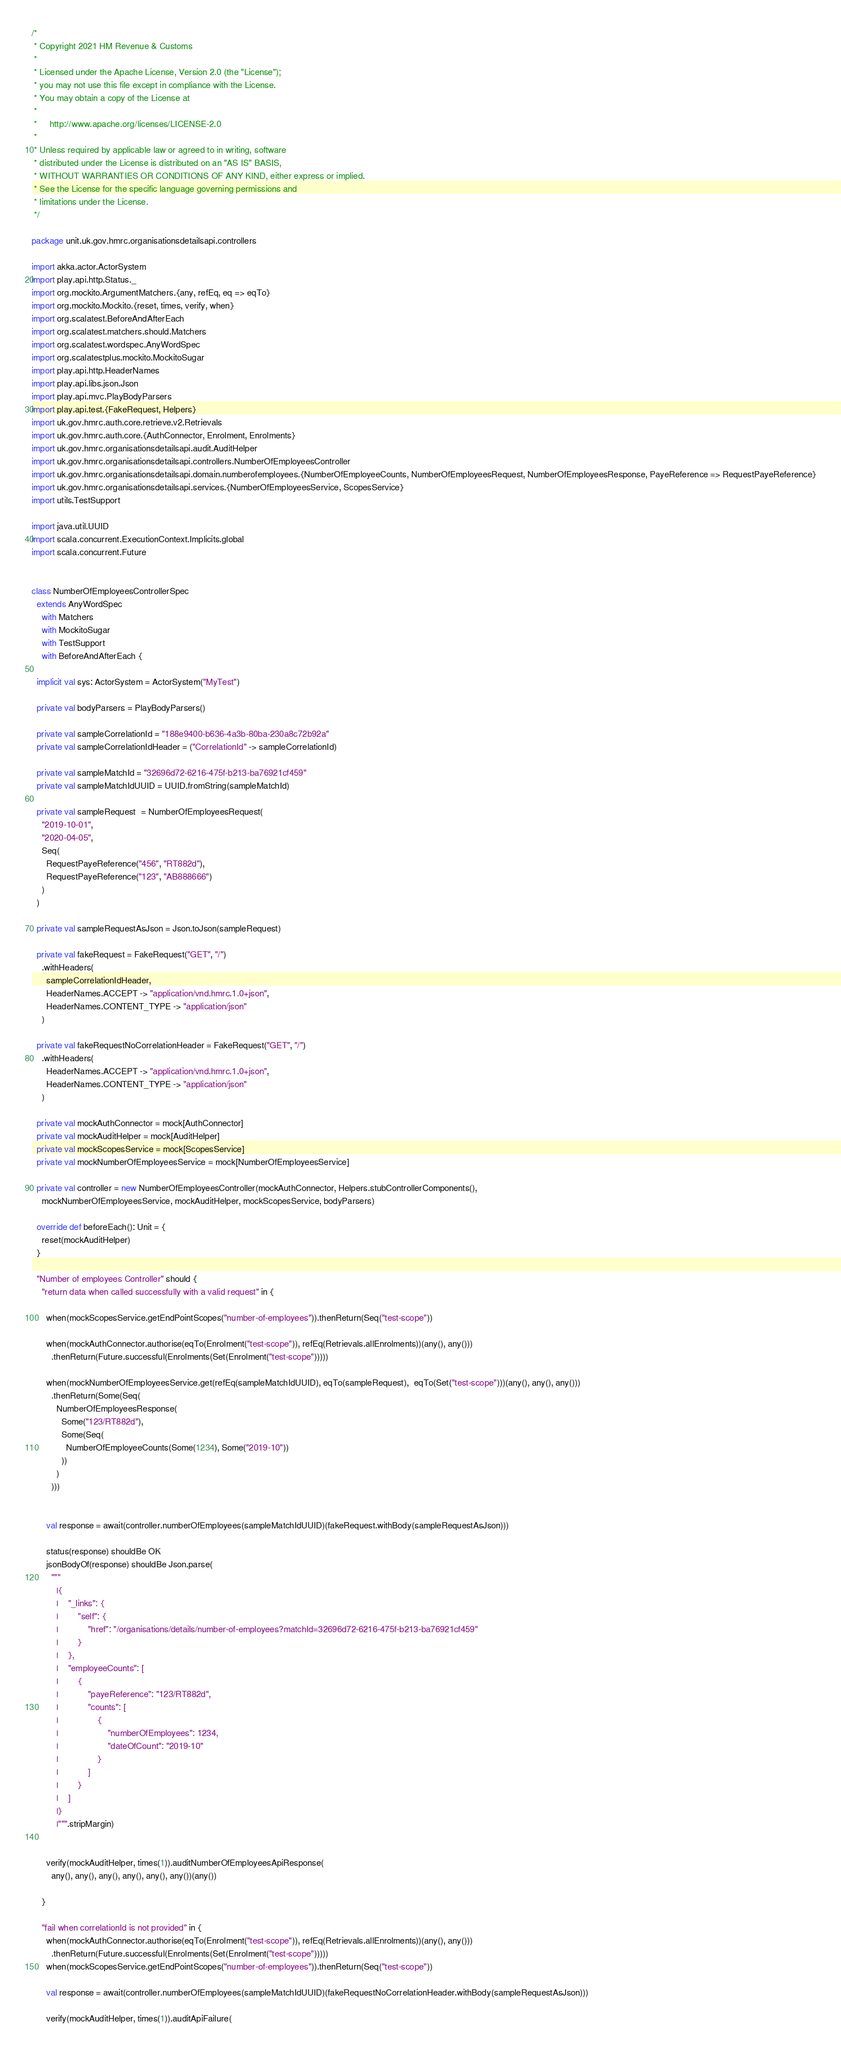Convert code to text. <code><loc_0><loc_0><loc_500><loc_500><_Scala_>/*
 * Copyright 2021 HM Revenue & Customs
 *
 * Licensed under the Apache License, Version 2.0 (the "License");
 * you may not use this file except in compliance with the License.
 * You may obtain a copy of the License at
 *
 *     http://www.apache.org/licenses/LICENSE-2.0
 *
 * Unless required by applicable law or agreed to in writing, software
 * distributed under the License is distributed on an "AS IS" BASIS,
 * WITHOUT WARRANTIES OR CONDITIONS OF ANY KIND, either express or implied.
 * See the License for the specific language governing permissions and
 * limitations under the License.
 */

package unit.uk.gov.hmrc.organisationsdetailsapi.controllers

import akka.actor.ActorSystem
import play.api.http.Status._
import org.mockito.ArgumentMatchers.{any, refEq, eq => eqTo}
import org.mockito.Mockito.{reset, times, verify, when}
import org.scalatest.BeforeAndAfterEach
import org.scalatest.matchers.should.Matchers
import org.scalatest.wordspec.AnyWordSpec
import org.scalatestplus.mockito.MockitoSugar
import play.api.http.HeaderNames
import play.api.libs.json.Json
import play.api.mvc.PlayBodyParsers
import play.api.test.{FakeRequest, Helpers}
import uk.gov.hmrc.auth.core.retrieve.v2.Retrievals
import uk.gov.hmrc.auth.core.{AuthConnector, Enrolment, Enrolments}
import uk.gov.hmrc.organisationsdetailsapi.audit.AuditHelper
import uk.gov.hmrc.organisationsdetailsapi.controllers.NumberOfEmployeesController
import uk.gov.hmrc.organisationsdetailsapi.domain.numberofemployees.{NumberOfEmployeeCounts, NumberOfEmployeesRequest, NumberOfEmployeesResponse, PayeReference => RequestPayeReference}
import uk.gov.hmrc.organisationsdetailsapi.services.{NumberOfEmployeesService, ScopesService}
import utils.TestSupport

import java.util.UUID
import scala.concurrent.ExecutionContext.Implicits.global
import scala.concurrent.Future


class NumberOfEmployeesControllerSpec
  extends AnyWordSpec
    with Matchers
    with MockitoSugar
    with TestSupport
    with BeforeAndAfterEach {

  implicit val sys: ActorSystem = ActorSystem("MyTest")

  private val bodyParsers = PlayBodyParsers()

  private val sampleCorrelationId = "188e9400-b636-4a3b-80ba-230a8c72b92a"
  private val sampleCorrelationIdHeader = ("CorrelationId" -> sampleCorrelationId)

  private val sampleMatchId = "32696d72-6216-475f-b213-ba76921cf459"
  private val sampleMatchIdUUID = UUID.fromString(sampleMatchId)

  private val sampleRequest  = NumberOfEmployeesRequest(
    "2019-10-01",
    "2020-04-05",
    Seq(
      RequestPayeReference("456", "RT882d"),
      RequestPayeReference("123", "AB888666")
    )
  )

  private val sampleRequestAsJson = Json.toJson(sampleRequest)

  private val fakeRequest = FakeRequest("GET", "/")
    .withHeaders(
      sampleCorrelationIdHeader,
      HeaderNames.ACCEPT -> "application/vnd.hmrc.1.0+json",
      HeaderNames.CONTENT_TYPE -> "application/json"
    )

  private val fakeRequestNoCorrelationHeader = FakeRequest("GET", "/")
    .withHeaders(
      HeaderNames.ACCEPT -> "application/vnd.hmrc.1.0+json",
      HeaderNames.CONTENT_TYPE -> "application/json"
    )

  private val mockAuthConnector = mock[AuthConnector]
  private val mockAuditHelper = mock[AuditHelper]
  private val mockScopesService = mock[ScopesService]
  private val mockNumberOfEmployeesService = mock[NumberOfEmployeesService]

  private val controller = new NumberOfEmployeesController(mockAuthConnector, Helpers.stubControllerComponents(),
    mockNumberOfEmployeesService, mockAuditHelper, mockScopesService, bodyParsers)

  override def beforeEach(): Unit = {
    reset(mockAuditHelper)
  }

  "Number of employees Controller" should {
    "return data when called successfully with a valid request" in {

      when(mockScopesService.getEndPointScopes("number-of-employees")).thenReturn(Seq("test-scope"))

      when(mockAuthConnector.authorise(eqTo(Enrolment("test-scope")), refEq(Retrievals.allEnrolments))(any(), any()))
        .thenReturn(Future.successful(Enrolments(Set(Enrolment("test-scope")))))

      when(mockNumberOfEmployeesService.get(refEq(sampleMatchIdUUID), eqTo(sampleRequest),  eqTo(Set("test-scope")))(any(), any(), any()))
        .thenReturn(Some(Seq(
          NumberOfEmployeesResponse(
            Some("123/RT882d"),
            Some(Seq(
              NumberOfEmployeeCounts(Some(1234), Some("2019-10"))
            ))
          )
        )))


      val response = await(controller.numberOfEmployees(sampleMatchIdUUID)(fakeRequest.withBody(sampleRequestAsJson)))

      status(response) shouldBe OK
      jsonBodyOf(response) shouldBe Json.parse(
        """
          |{
          |    "_links": {
          |        "self": {
          |            "href": "/organisations/details/number-of-employees?matchId=32696d72-6216-475f-b213-ba76921cf459"
          |        }
          |    },
          |    "employeeCounts": [
          |        {
          |            "payeReference": "123/RT882d",
          |            "counts": [
          |                {
          |                    "numberOfEmployees": 1234,
          |                    "dateOfCount": "2019-10"
          |                }
          |            ]
          |        }
          |    ]
          |}
          |""".stripMargin)


      verify(mockAuditHelper, times(1)).auditNumberOfEmployeesApiResponse(
        any(), any(), any(), any(), any(), any())(any())

    }

    "fail when correlationId is not provided" in {
      when(mockAuthConnector.authorise(eqTo(Enrolment("test-scope")), refEq(Retrievals.allEnrolments))(any(), any()))
        .thenReturn(Future.successful(Enrolments(Set(Enrolment("test-scope")))))
      when(mockScopesService.getEndPointScopes("number-of-employees")).thenReturn(Seq("test-scope"))

      val response = await(controller.numberOfEmployees(sampleMatchIdUUID)(fakeRequestNoCorrelationHeader.withBody(sampleRequestAsJson)))

      verify(mockAuditHelper, times(1)).auditApiFailure(</code> 